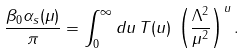<formula> <loc_0><loc_0><loc_500><loc_500>\frac { \beta _ { 0 } \alpha _ { s } ( \mu ) } { \pi } = \int _ { 0 } ^ { \infty } { d u } \, T ( u ) \, \left ( \frac { \Lambda ^ { 2 } } { \mu ^ { 2 } } \right ) ^ { u } .</formula> 